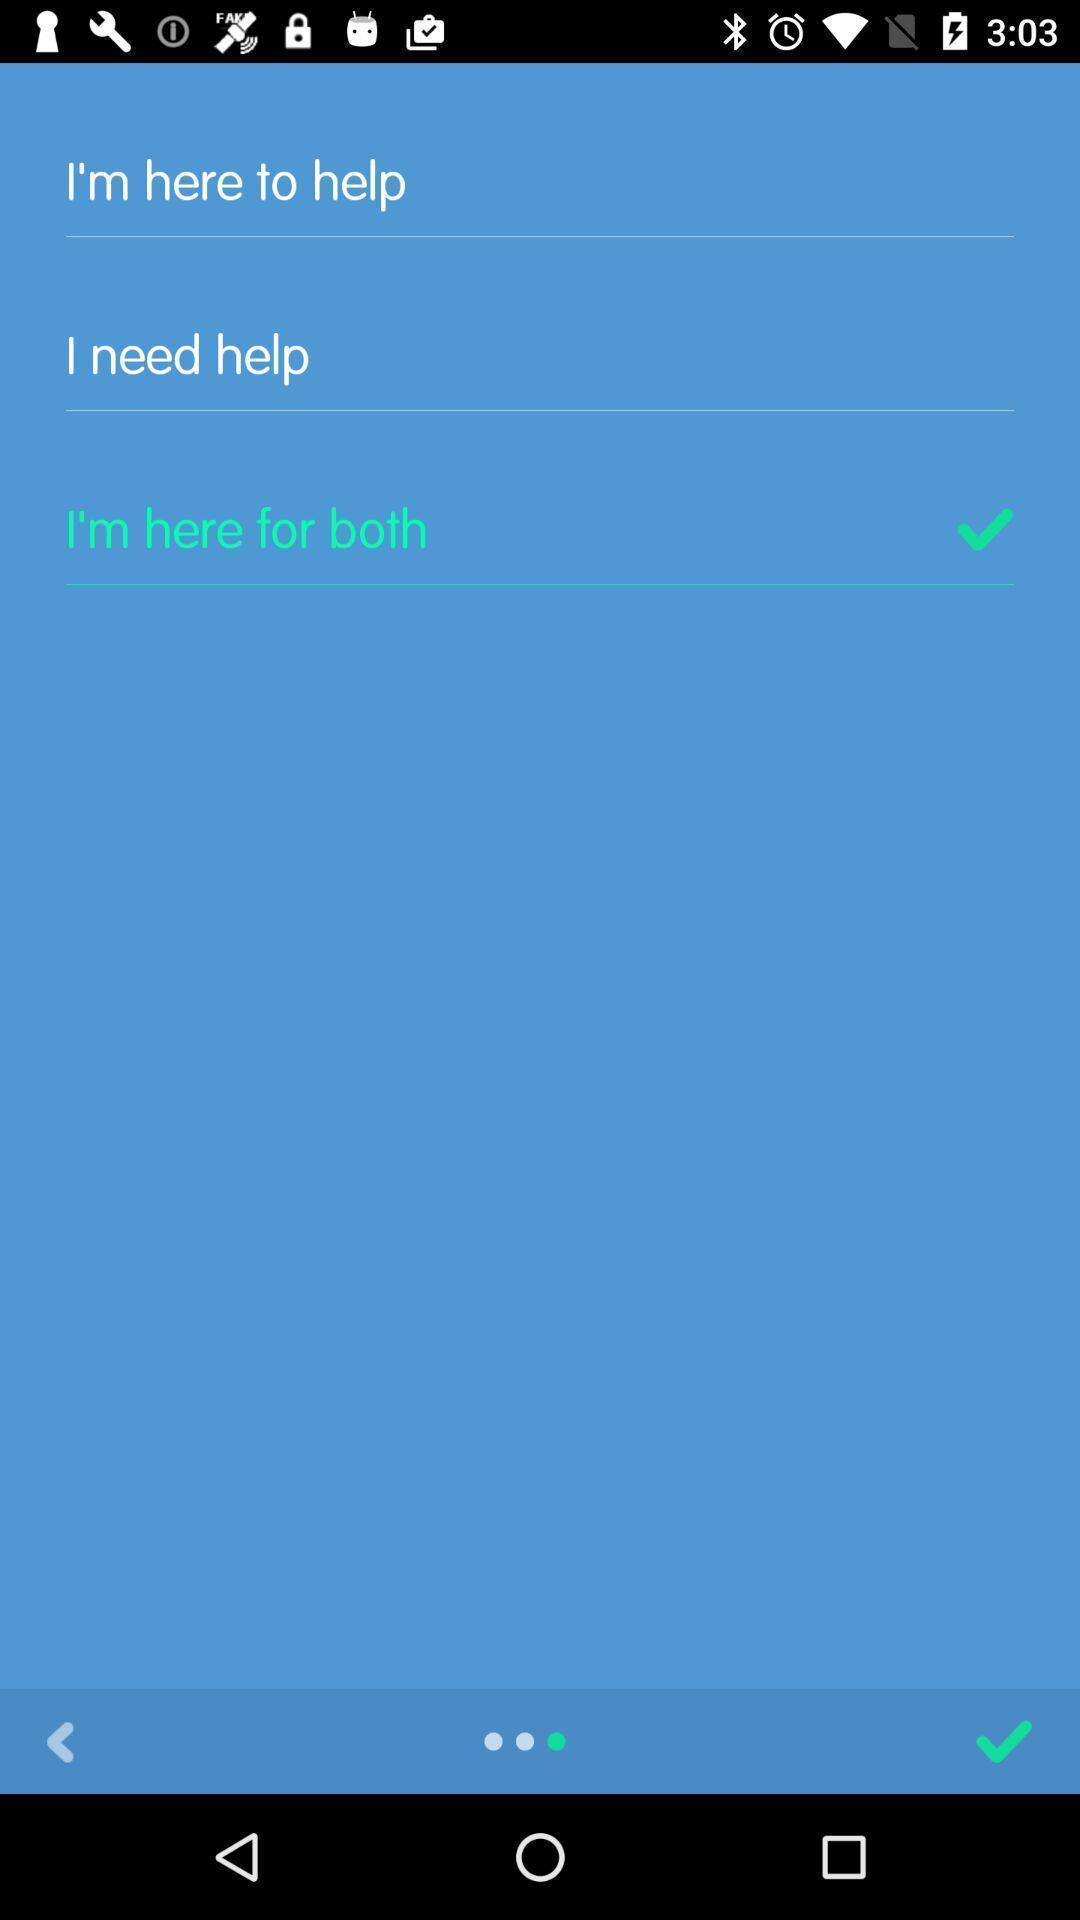Provide a description of this screenshot. Screen displaying to select the option. 